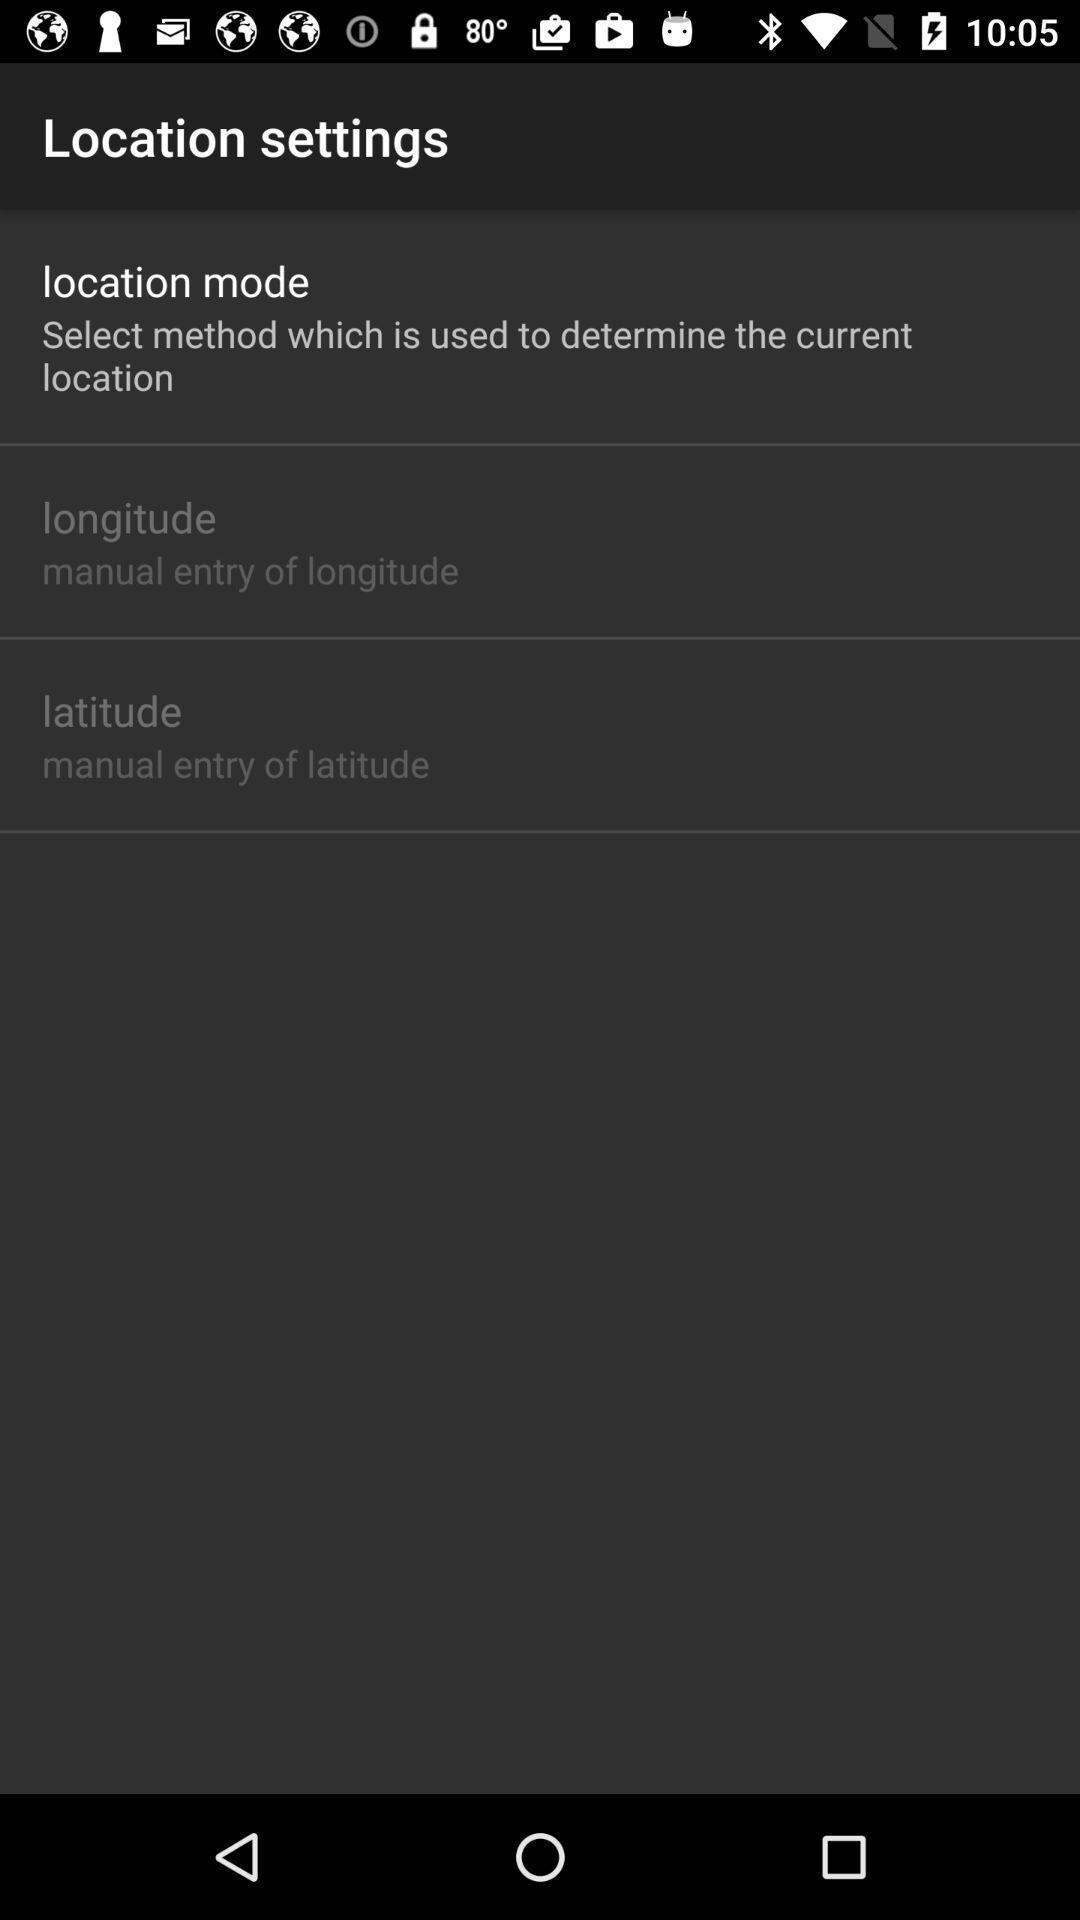Provide a detailed account of this screenshot. Screen showing some location settings. 